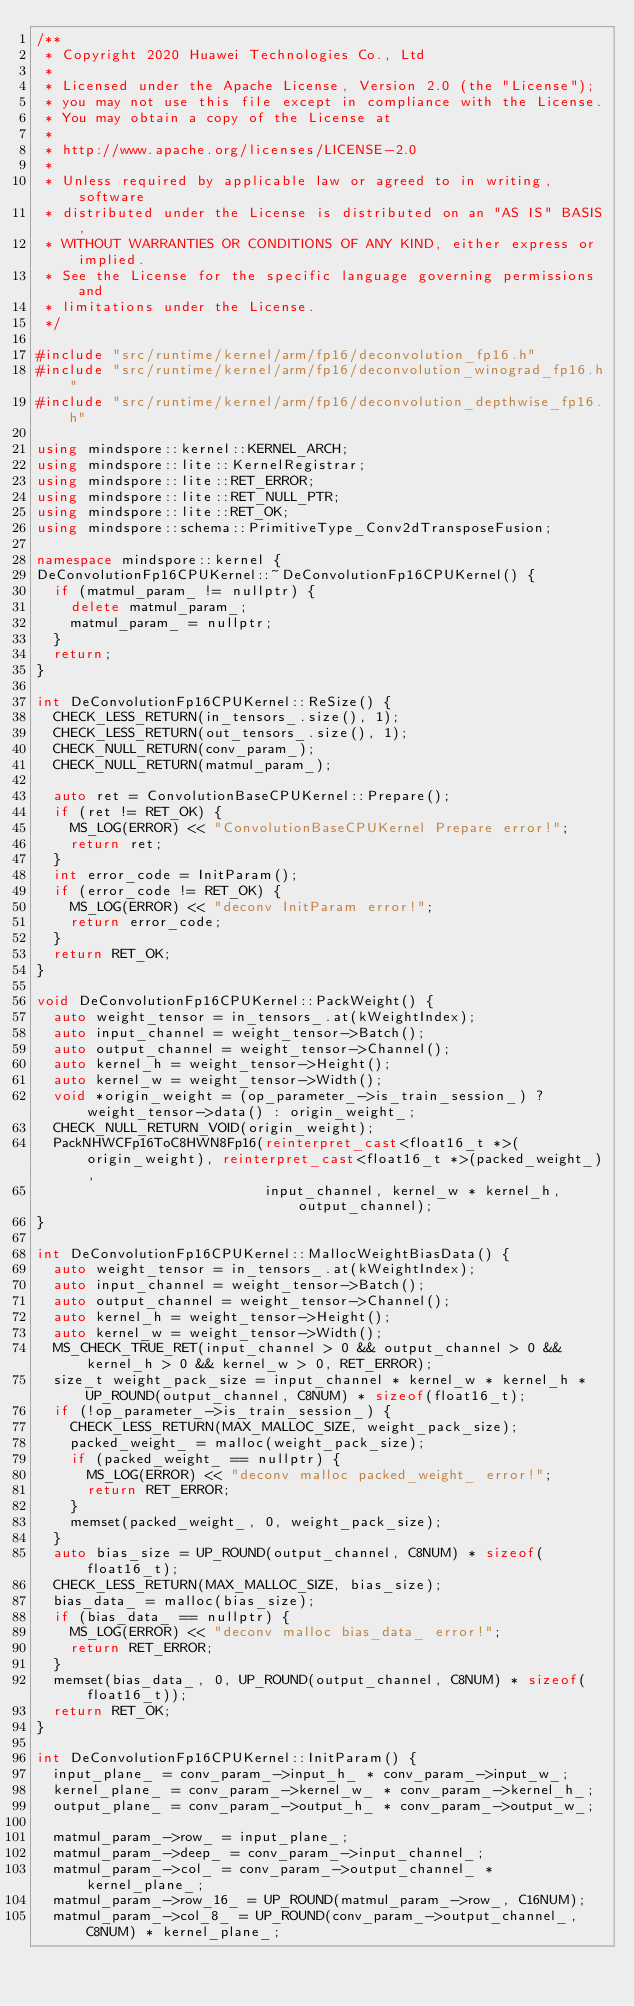Convert code to text. <code><loc_0><loc_0><loc_500><loc_500><_C++_>/**
 * Copyright 2020 Huawei Technologies Co., Ltd
 *
 * Licensed under the Apache License, Version 2.0 (the "License");
 * you may not use this file except in compliance with the License.
 * You may obtain a copy of the License at
 *
 * http://www.apache.org/licenses/LICENSE-2.0
 *
 * Unless required by applicable law or agreed to in writing, software
 * distributed under the License is distributed on an "AS IS" BASIS,
 * WITHOUT WARRANTIES OR CONDITIONS OF ANY KIND, either express or implied.
 * See the License for the specific language governing permissions and
 * limitations under the License.
 */

#include "src/runtime/kernel/arm/fp16/deconvolution_fp16.h"
#include "src/runtime/kernel/arm/fp16/deconvolution_winograd_fp16.h"
#include "src/runtime/kernel/arm/fp16/deconvolution_depthwise_fp16.h"

using mindspore::kernel::KERNEL_ARCH;
using mindspore::lite::KernelRegistrar;
using mindspore::lite::RET_ERROR;
using mindspore::lite::RET_NULL_PTR;
using mindspore::lite::RET_OK;
using mindspore::schema::PrimitiveType_Conv2dTransposeFusion;

namespace mindspore::kernel {
DeConvolutionFp16CPUKernel::~DeConvolutionFp16CPUKernel() {
  if (matmul_param_ != nullptr) {
    delete matmul_param_;
    matmul_param_ = nullptr;
  }
  return;
}

int DeConvolutionFp16CPUKernel::ReSize() {
  CHECK_LESS_RETURN(in_tensors_.size(), 1);
  CHECK_LESS_RETURN(out_tensors_.size(), 1);
  CHECK_NULL_RETURN(conv_param_);
  CHECK_NULL_RETURN(matmul_param_);

  auto ret = ConvolutionBaseCPUKernel::Prepare();
  if (ret != RET_OK) {
    MS_LOG(ERROR) << "ConvolutionBaseCPUKernel Prepare error!";
    return ret;
  }
  int error_code = InitParam();
  if (error_code != RET_OK) {
    MS_LOG(ERROR) << "deconv InitParam error!";
    return error_code;
  }
  return RET_OK;
}

void DeConvolutionFp16CPUKernel::PackWeight() {
  auto weight_tensor = in_tensors_.at(kWeightIndex);
  auto input_channel = weight_tensor->Batch();
  auto output_channel = weight_tensor->Channel();
  auto kernel_h = weight_tensor->Height();
  auto kernel_w = weight_tensor->Width();
  void *origin_weight = (op_parameter_->is_train_session_) ? weight_tensor->data() : origin_weight_;
  CHECK_NULL_RETURN_VOID(origin_weight);
  PackNHWCFp16ToC8HWN8Fp16(reinterpret_cast<float16_t *>(origin_weight), reinterpret_cast<float16_t *>(packed_weight_),
                           input_channel, kernel_w * kernel_h, output_channel);
}

int DeConvolutionFp16CPUKernel::MallocWeightBiasData() {
  auto weight_tensor = in_tensors_.at(kWeightIndex);
  auto input_channel = weight_tensor->Batch();
  auto output_channel = weight_tensor->Channel();
  auto kernel_h = weight_tensor->Height();
  auto kernel_w = weight_tensor->Width();
  MS_CHECK_TRUE_RET(input_channel > 0 && output_channel > 0 && kernel_h > 0 && kernel_w > 0, RET_ERROR);
  size_t weight_pack_size = input_channel * kernel_w * kernel_h * UP_ROUND(output_channel, C8NUM) * sizeof(float16_t);
  if (!op_parameter_->is_train_session_) {
    CHECK_LESS_RETURN(MAX_MALLOC_SIZE, weight_pack_size);
    packed_weight_ = malloc(weight_pack_size);
    if (packed_weight_ == nullptr) {
      MS_LOG(ERROR) << "deconv malloc packed_weight_ error!";
      return RET_ERROR;
    }
    memset(packed_weight_, 0, weight_pack_size);
  }
  auto bias_size = UP_ROUND(output_channel, C8NUM) * sizeof(float16_t);
  CHECK_LESS_RETURN(MAX_MALLOC_SIZE, bias_size);
  bias_data_ = malloc(bias_size);
  if (bias_data_ == nullptr) {
    MS_LOG(ERROR) << "deconv malloc bias_data_ error!";
    return RET_ERROR;
  }
  memset(bias_data_, 0, UP_ROUND(output_channel, C8NUM) * sizeof(float16_t));
  return RET_OK;
}

int DeConvolutionFp16CPUKernel::InitParam() {
  input_plane_ = conv_param_->input_h_ * conv_param_->input_w_;
  kernel_plane_ = conv_param_->kernel_w_ * conv_param_->kernel_h_;
  output_plane_ = conv_param_->output_h_ * conv_param_->output_w_;

  matmul_param_->row_ = input_plane_;
  matmul_param_->deep_ = conv_param_->input_channel_;
  matmul_param_->col_ = conv_param_->output_channel_ * kernel_plane_;
  matmul_param_->row_16_ = UP_ROUND(matmul_param_->row_, C16NUM);
  matmul_param_->col_8_ = UP_ROUND(conv_param_->output_channel_, C8NUM) * kernel_plane_;
</code> 